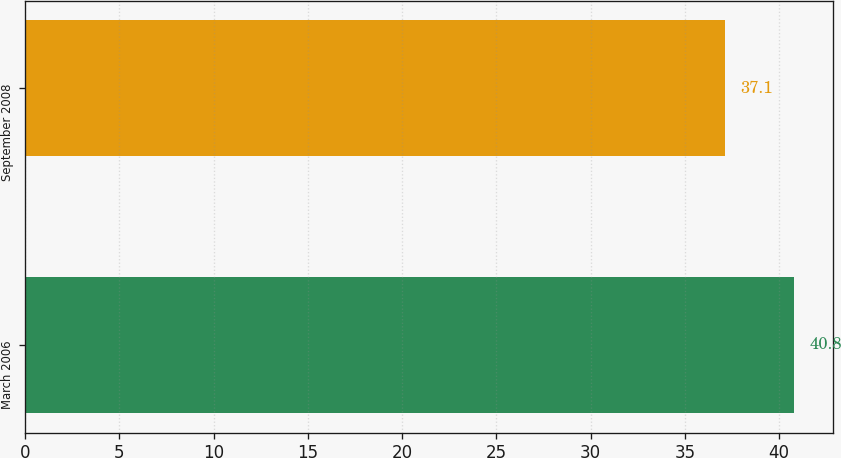Convert chart. <chart><loc_0><loc_0><loc_500><loc_500><bar_chart><fcel>March 2006<fcel>September 2008<nl><fcel>40.8<fcel>37.1<nl></chart> 